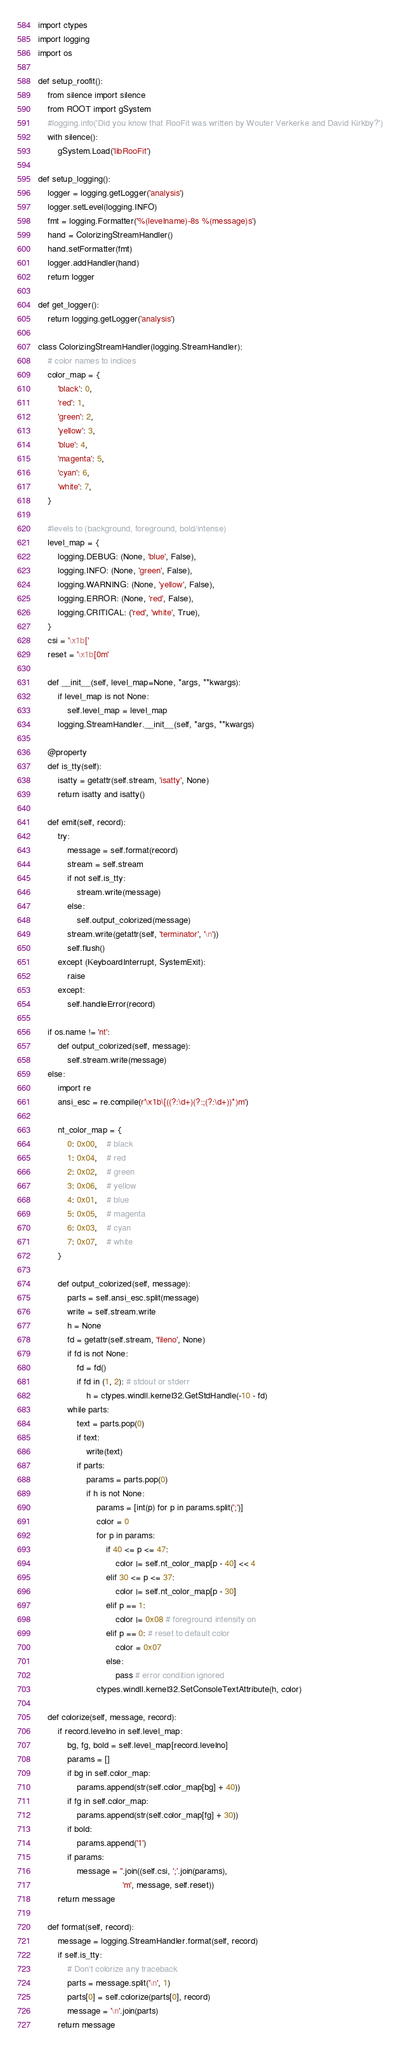Convert code to text. <code><loc_0><loc_0><loc_500><loc_500><_Python_>
import ctypes
import logging
import os

def setup_roofit():
    from silence import silence
    from ROOT import gSystem
    #logging.info('Did you know that RooFit was written by Wouter Verkerke and David Kirkby?')
    with silence():
        gSystem.Load('libRooFit')

def setup_logging():
    logger = logging.getLogger('analysis')
    logger.setLevel(logging.INFO)
    fmt = logging.Formatter('%(levelname)-8s %(message)s')
    hand = ColorizingStreamHandler()
    hand.setFormatter(fmt)
    logger.addHandler(hand)
    return logger

def get_logger():
    return logging.getLogger('analysis')

class ColorizingStreamHandler(logging.StreamHandler):
    # color names to indices
    color_map = {
        'black': 0,
        'red': 1,
        'green': 2,
        'yellow': 3,
        'blue': 4,
        'magenta': 5,
        'cyan': 6,
        'white': 7,
    }

    #levels to (background, foreground, bold/intense)
    level_map = {
        logging.DEBUG: (None, 'blue', False),
        logging.INFO: (None, 'green', False),
        logging.WARNING: (None, 'yellow', False),
        logging.ERROR: (None, 'red', False),
        logging.CRITICAL: ('red', 'white', True),
    }
    csi = '\x1b['
    reset = '\x1b[0m'

    def __init__(self, level_map=None, *args, **kwargs):
        if level_map is not None:
            self.level_map = level_map
        logging.StreamHandler.__init__(self, *args, **kwargs)

    @property
    def is_tty(self):
        isatty = getattr(self.stream, 'isatty', None)
        return isatty and isatty()

    def emit(self, record):
        try:
            message = self.format(record)
            stream = self.stream
            if not self.is_tty:
                stream.write(message)
            else:
                self.output_colorized(message)
            stream.write(getattr(self, 'terminator', '\n'))
            self.flush()
        except (KeyboardInterrupt, SystemExit):
            raise
        except:
            self.handleError(record)

    if os.name != 'nt':
        def output_colorized(self, message):
            self.stream.write(message)
    else:
        import re
        ansi_esc = re.compile(r'\x1b\[((?:\d+)(?:;(?:\d+))*)m')

        nt_color_map = {
            0: 0x00,    # black
            1: 0x04,    # red
            2: 0x02,    # green
            3: 0x06,    # yellow
            4: 0x01,    # blue
            5: 0x05,    # magenta
            6: 0x03,    # cyan
            7: 0x07,    # white
        }

        def output_colorized(self, message):
            parts = self.ansi_esc.split(message)
            write = self.stream.write
            h = None
            fd = getattr(self.stream, 'fileno', None)
            if fd is not None:
                fd = fd()
                if fd in (1, 2): # stdout or stderr
                    h = ctypes.windll.kernel32.GetStdHandle(-10 - fd)
            while parts:
                text = parts.pop(0)
                if text:
                    write(text)
                if parts:
                    params = parts.pop(0)
                    if h is not None:
                        params = [int(p) for p in params.split(';')]
                        color = 0
                        for p in params:
                            if 40 <= p <= 47:
                                color |= self.nt_color_map[p - 40] << 4
                            elif 30 <= p <= 37:
                                color |= self.nt_color_map[p - 30]
                            elif p == 1:
                                color |= 0x08 # foreground intensity on
                            elif p == 0: # reset to default color
                                color = 0x07
                            else:
                                pass # error condition ignored
                        ctypes.windll.kernel32.SetConsoleTextAttribute(h, color)

    def colorize(self, message, record):
        if record.levelno in self.level_map:
            bg, fg, bold = self.level_map[record.levelno]
            params = []
            if bg in self.color_map:
                params.append(str(self.color_map[bg] + 40))
            if fg in self.color_map:
                params.append(str(self.color_map[fg] + 30))
            if bold:
                params.append('1')
            if params:
                message = ''.join((self.csi, ';'.join(params),
                                   'm', message, self.reset))
        return message

    def format(self, record):
        message = logging.StreamHandler.format(self, record)
        if self.is_tty:
            # Don't colorize any traceback
            parts = message.split('\n', 1)
            parts[0] = self.colorize(parts[0], record)
            message = '\n'.join(parts)
        return message

</code> 